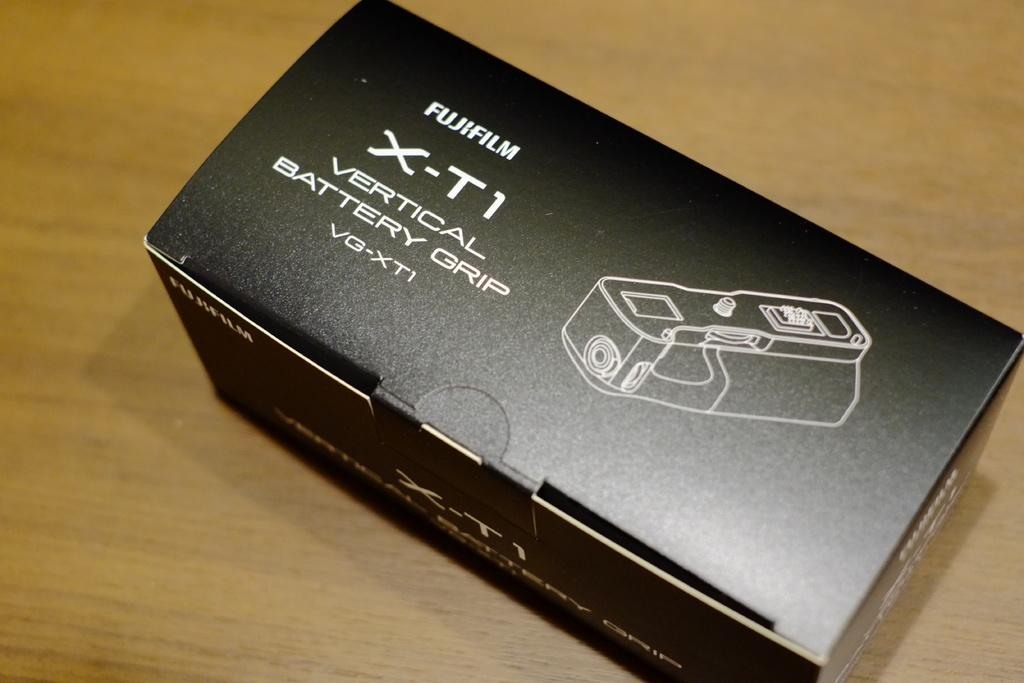<image>
Render a clear and concise summary of the photo. A black box contains a vertical battery grip. 